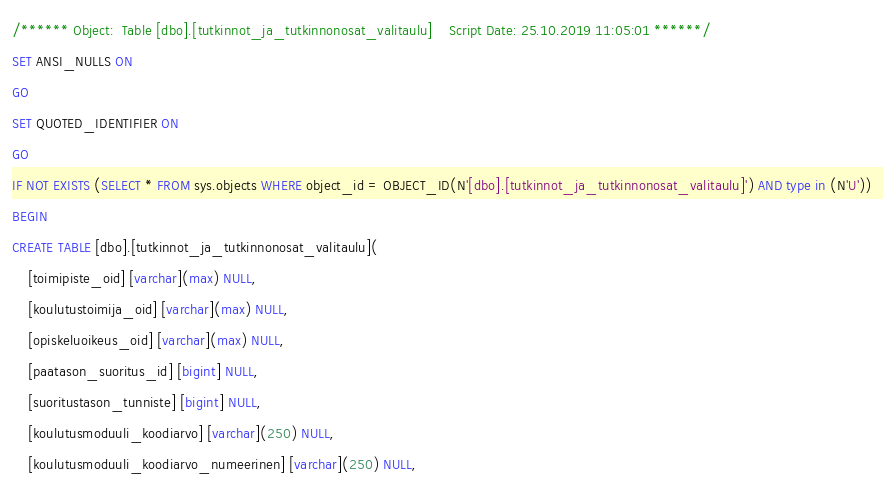Convert code to text. <code><loc_0><loc_0><loc_500><loc_500><_SQL_>/****** Object:  Table [dbo].[tutkinnot_ja_tutkinnonosat_valitaulu]    Script Date: 25.10.2019 11:05:01 ******/
SET ANSI_NULLS ON
GO
SET QUOTED_IDENTIFIER ON
GO
IF NOT EXISTS (SELECT * FROM sys.objects WHERE object_id = OBJECT_ID(N'[dbo].[tutkinnot_ja_tutkinnonosat_valitaulu]') AND type in (N'U'))
BEGIN
CREATE TABLE [dbo].[tutkinnot_ja_tutkinnonosat_valitaulu](
	[toimipiste_oid] [varchar](max) NULL,
	[koulutustoimija_oid] [varchar](max) NULL,
	[opiskeluoikeus_oid] [varchar](max) NULL,
	[paatason_suoritus_id] [bigint] NULL,
	[suoritustason_tunniste] [bigint] NULL,
	[koulutusmoduuli_koodiarvo] [varchar](250) NULL,
	[koulutusmoduuli_koodiarvo_numeerinen] [varchar](250) NULL,</code> 